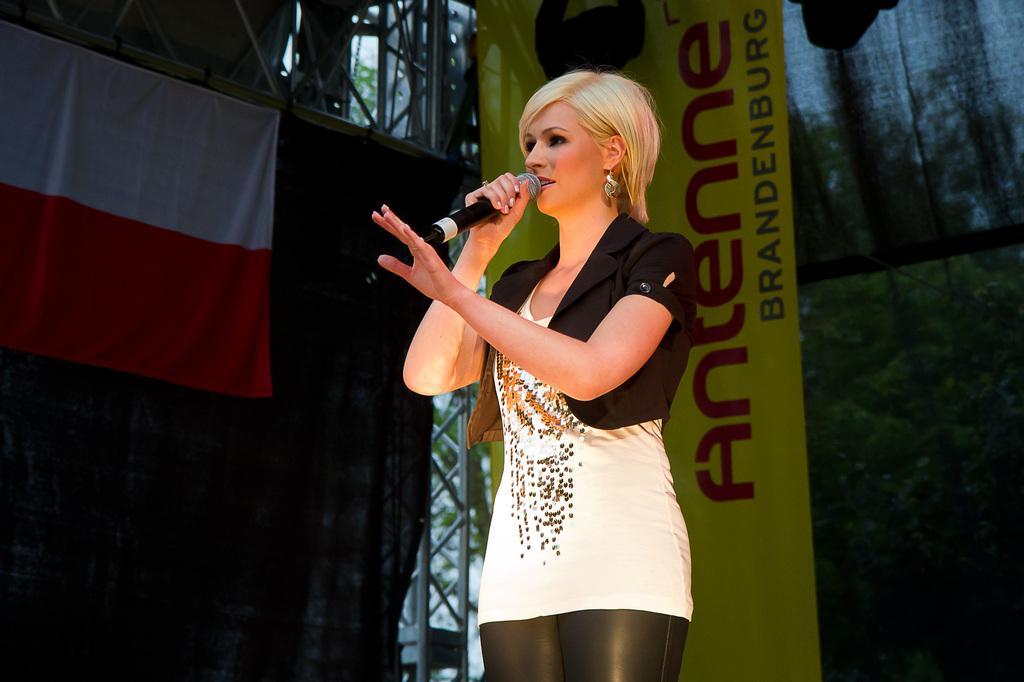Please provide a concise description of this image. As we can see in the image there is a banner and a woman holding mic. 